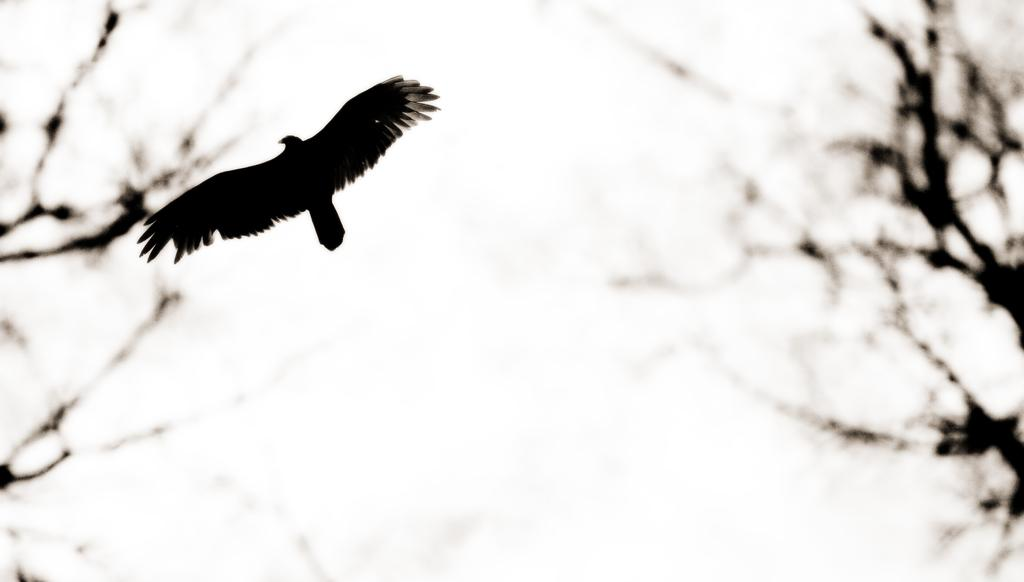What type of animal can be seen in the image? There is a bird in the image. What is the bird doing in the image? The bird is flying in the air. What can be seen in the background of the image? There are trees and the sky visible in the background of the image. What type of calculator is the bird using while flying in the image? There is no calculator present in the image, and birds do not use calculators. 